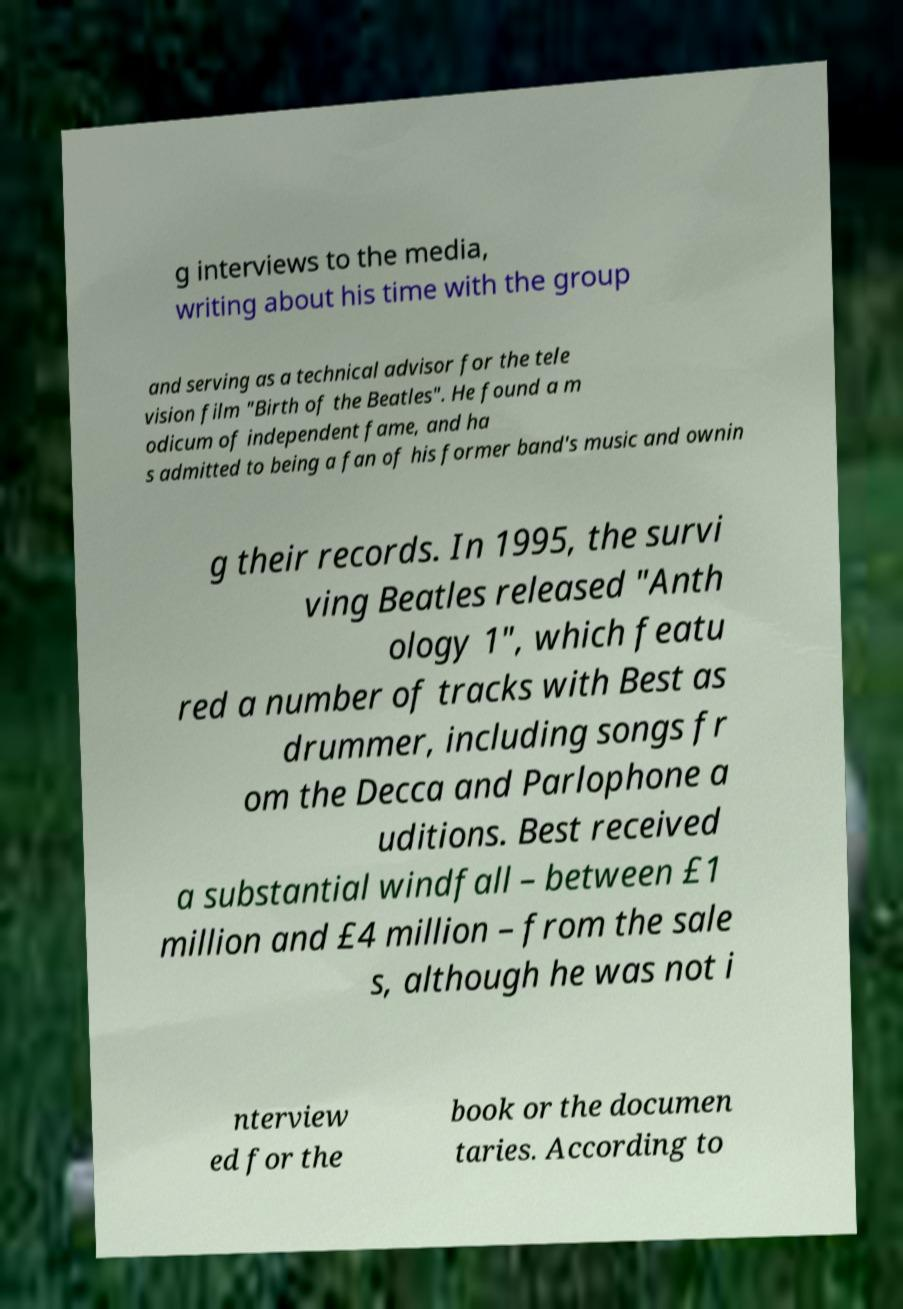Could you assist in decoding the text presented in this image and type it out clearly? g interviews to the media, writing about his time with the group and serving as a technical advisor for the tele vision film "Birth of the Beatles". He found a m odicum of independent fame, and ha s admitted to being a fan of his former band's music and ownin g their records. In 1995, the survi ving Beatles released "Anth ology 1", which featu red a number of tracks with Best as drummer, including songs fr om the Decca and Parlophone a uditions. Best received a substantial windfall – between £1 million and £4 million – from the sale s, although he was not i nterview ed for the book or the documen taries. According to 